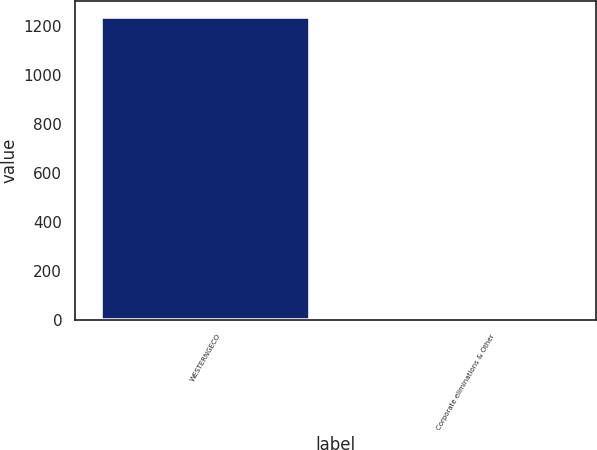<chart> <loc_0><loc_0><loc_500><loc_500><bar_chart><fcel>WESTERNGECO<fcel>Corporate eliminations & Other<nl><fcel>1238<fcel>3<nl></chart> 